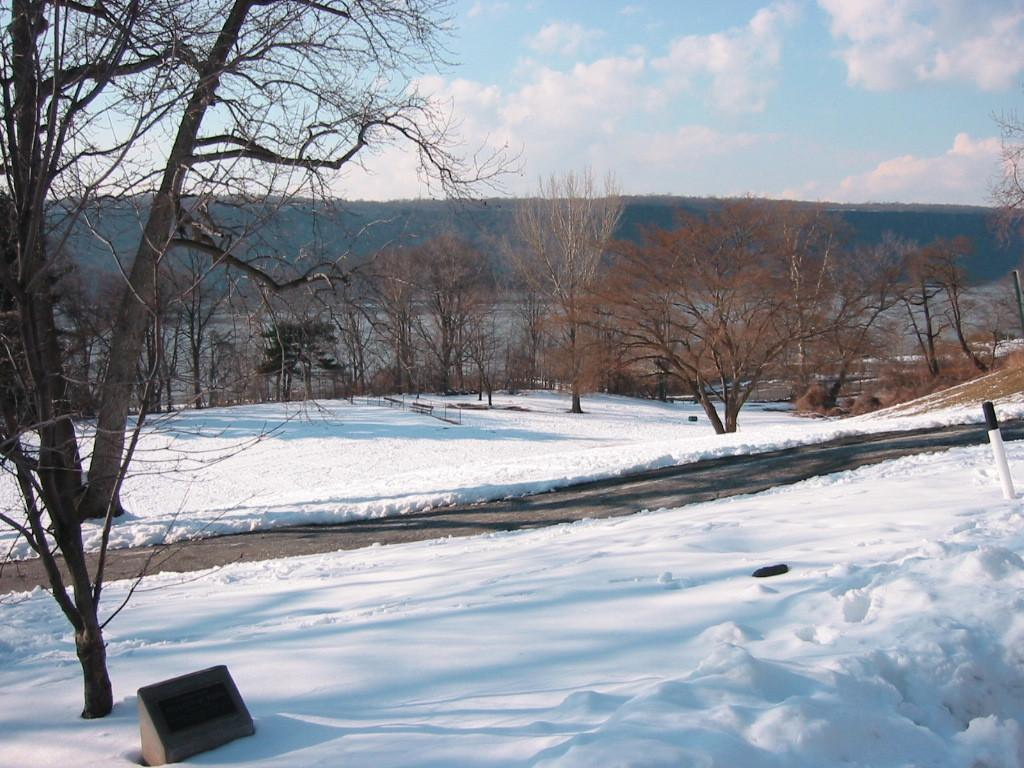What is covering the ground in the image? There is snow on the ground in the image. What is the condition of the tree in the image? There is a dry tree in the image. What can be seen in the background of the image? There are trees and mountains in the background of the image. What is the weather like in the image? The sky is cloudy in the image. Can you see the kitten painting the snow in the image? There is no kitten or painting activity present in the image. What color is the kitten using to paint the snow? There is no kitten or paint present in the image, so we cannot determine the color being used. 